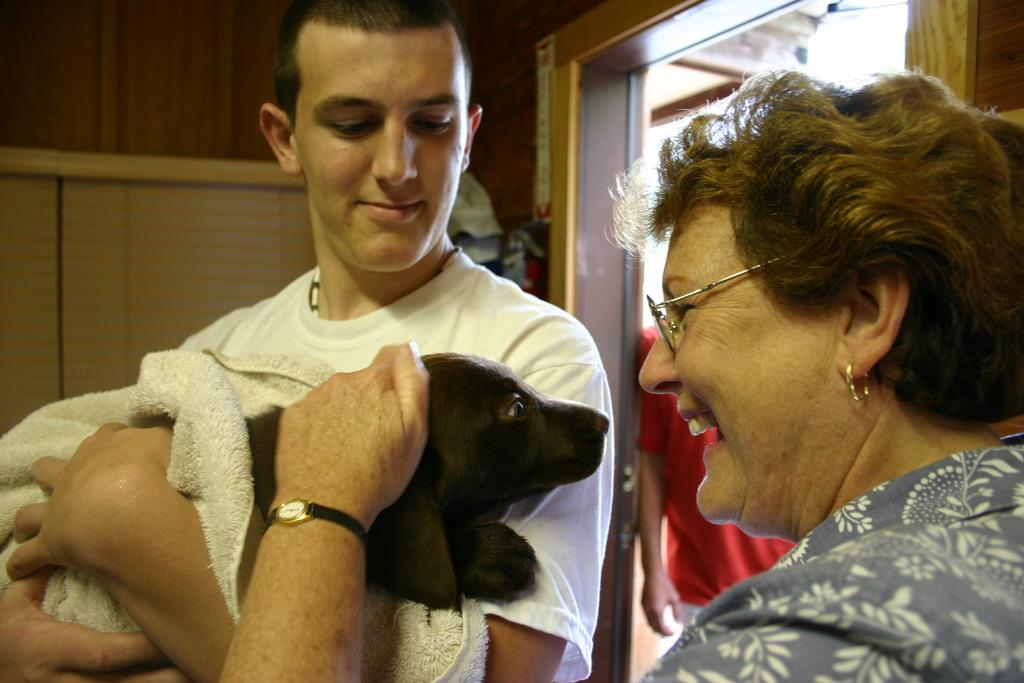How many people are in the image? There are three persons standing in the image. What are two of the persons doing with the dog? Two of the persons are holding a dog. What can be seen in the background of the image? There is a wall visible in the background of the image. What type of orange is being used to perform calculations in the image? There is no orange or calculator present in the image. 